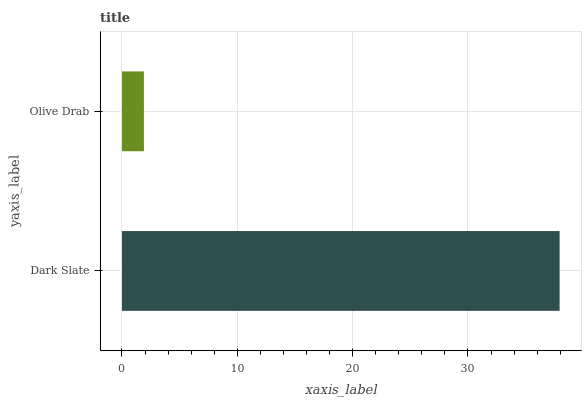Is Olive Drab the minimum?
Answer yes or no. Yes. Is Dark Slate the maximum?
Answer yes or no. Yes. Is Olive Drab the maximum?
Answer yes or no. No. Is Dark Slate greater than Olive Drab?
Answer yes or no. Yes. Is Olive Drab less than Dark Slate?
Answer yes or no. Yes. Is Olive Drab greater than Dark Slate?
Answer yes or no. No. Is Dark Slate less than Olive Drab?
Answer yes or no. No. Is Dark Slate the high median?
Answer yes or no. Yes. Is Olive Drab the low median?
Answer yes or no. Yes. Is Olive Drab the high median?
Answer yes or no. No. Is Dark Slate the low median?
Answer yes or no. No. 